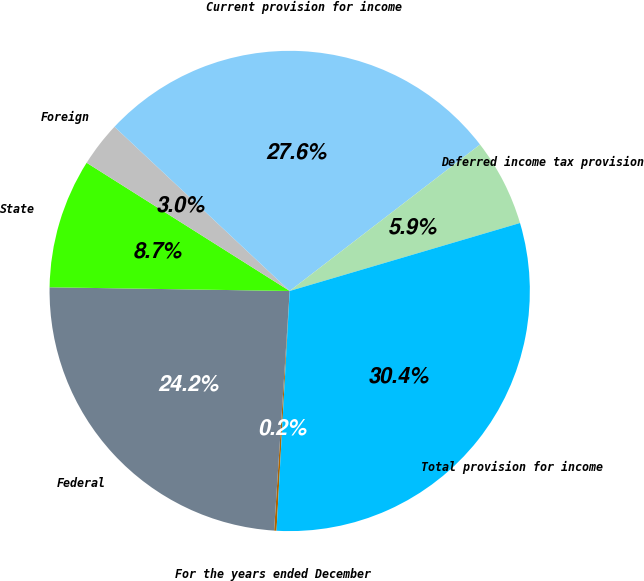<chart> <loc_0><loc_0><loc_500><loc_500><pie_chart><fcel>For the years ended December<fcel>Federal<fcel>State<fcel>Foreign<fcel>Current provision for income<fcel>Deferred income tax provision<fcel>Total provision for income<nl><fcel>0.16%<fcel>24.21%<fcel>8.72%<fcel>3.02%<fcel>27.58%<fcel>5.87%<fcel>30.44%<nl></chart> 